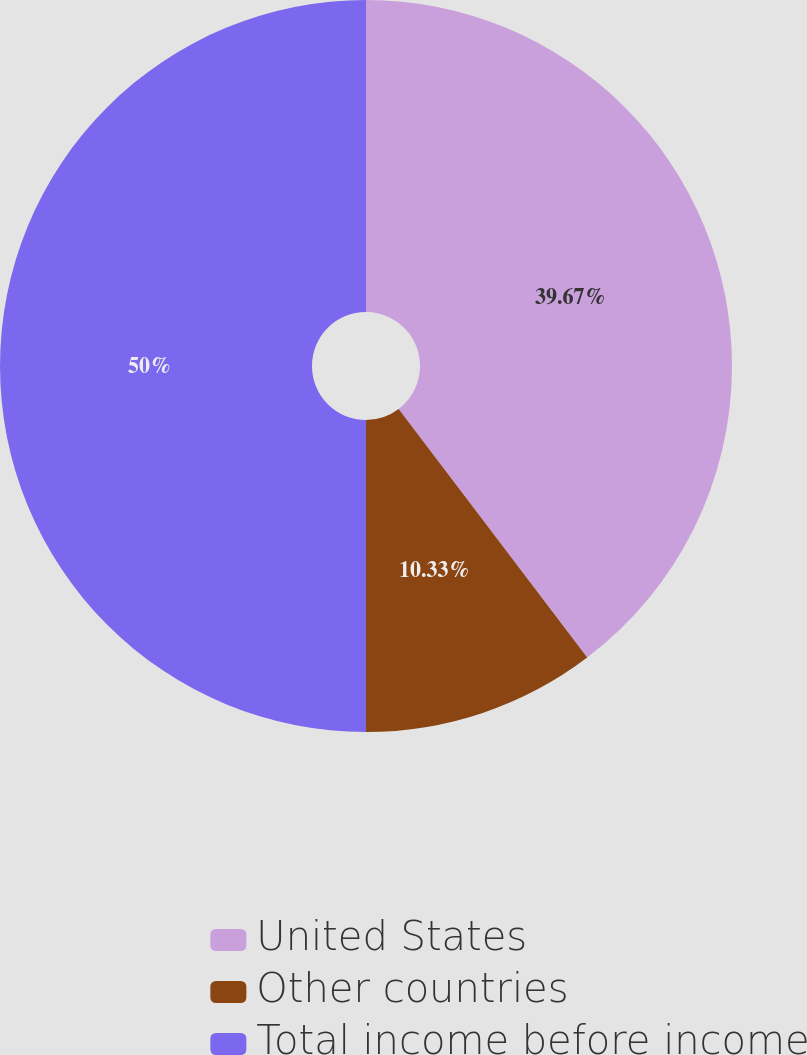Convert chart to OTSL. <chart><loc_0><loc_0><loc_500><loc_500><pie_chart><fcel>United States<fcel>Other countries<fcel>Total income before income<nl><fcel>39.67%<fcel>10.33%<fcel>50.0%<nl></chart> 